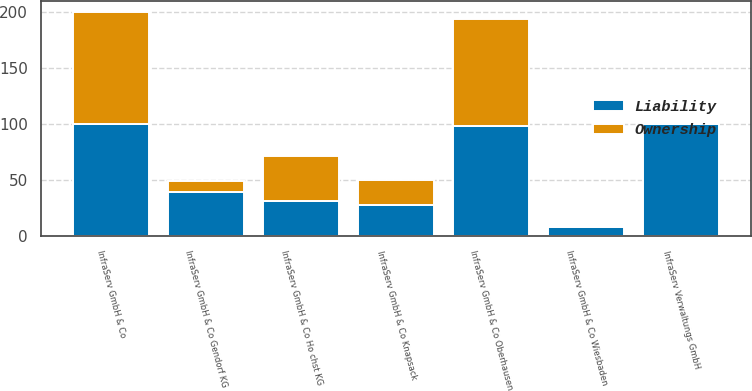<chart> <loc_0><loc_0><loc_500><loc_500><stacked_bar_chart><ecel><fcel>InfraServ GmbH & Co Gendorf KG<fcel>InfraServ GmbH & Co Oberhausen<fcel>InfraServ GmbH & Co Knapsack<fcel>InfraServ GmbH & Co<fcel>InfraServ GmbH & Co Ho chst KG<fcel>InfraServ GmbH & Co Wiesbaden<fcel>InfraServ Verwaltungs GmbH<nl><fcel>Liability<fcel>39<fcel>98<fcel>28.2<fcel>100<fcel>31.2<fcel>7.9<fcel>100<nl><fcel>Ownership<fcel>10<fcel>96<fcel>22<fcel>100<fcel>40<fcel>0<fcel>0<nl></chart> 